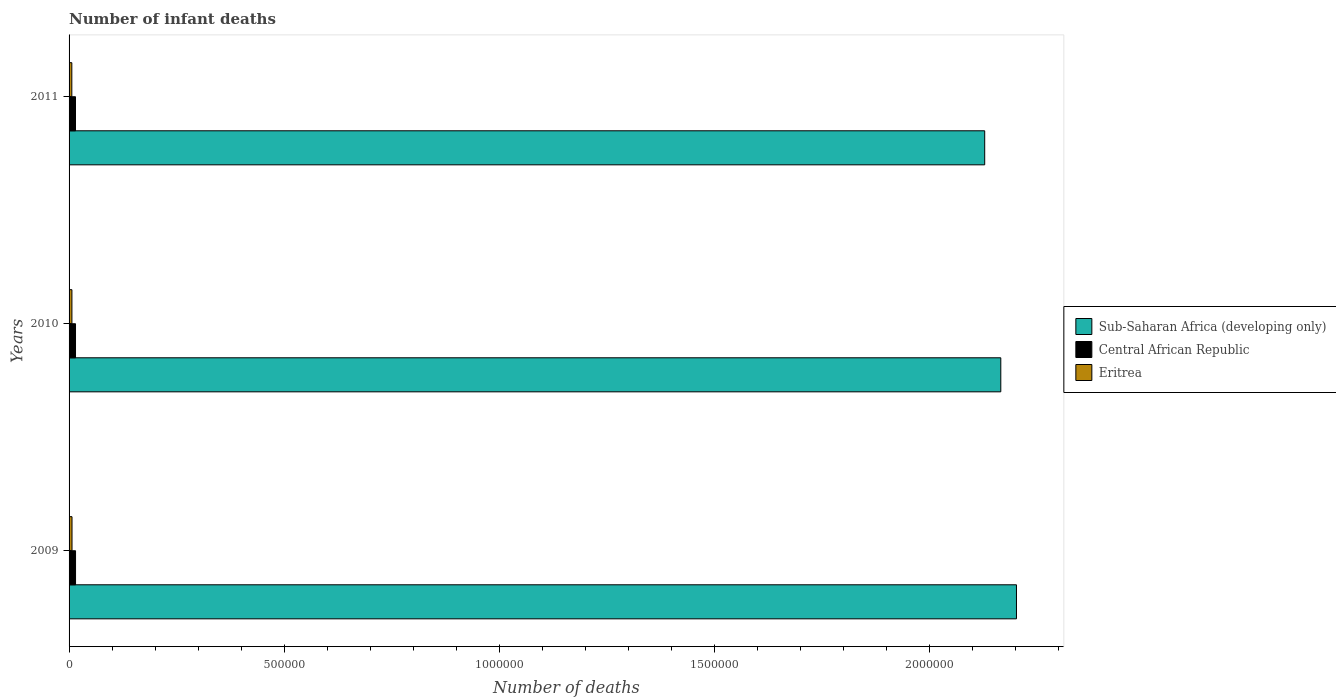How many groups of bars are there?
Provide a short and direct response. 3. Are the number of bars on each tick of the Y-axis equal?
Give a very brief answer. Yes. How many bars are there on the 1st tick from the bottom?
Your response must be concise. 3. What is the number of infant deaths in Sub-Saharan Africa (developing only) in 2009?
Provide a short and direct response. 2.20e+06. Across all years, what is the maximum number of infant deaths in Central African Republic?
Give a very brief answer. 1.51e+04. Across all years, what is the minimum number of infant deaths in Sub-Saharan Africa (developing only)?
Give a very brief answer. 2.13e+06. What is the total number of infant deaths in Eritrea in the graph?
Your answer should be very brief. 1.98e+04. What is the difference between the number of infant deaths in Eritrea in 2009 and that in 2011?
Ensure brevity in your answer.  431. What is the difference between the number of infant deaths in Eritrea in 2009 and the number of infant deaths in Sub-Saharan Africa (developing only) in 2011?
Give a very brief answer. -2.12e+06. What is the average number of infant deaths in Eritrea per year?
Ensure brevity in your answer.  6615.33. In the year 2010, what is the difference between the number of infant deaths in Sub-Saharan Africa (developing only) and number of infant deaths in Eritrea?
Provide a short and direct response. 2.16e+06. What is the ratio of the number of infant deaths in Eritrea in 2009 to that in 2011?
Your response must be concise. 1.07. Is the number of infant deaths in Central African Republic in 2009 less than that in 2011?
Offer a terse response. No. Is the difference between the number of infant deaths in Sub-Saharan Africa (developing only) in 2009 and 2011 greater than the difference between the number of infant deaths in Eritrea in 2009 and 2011?
Provide a succinct answer. Yes. What is the difference between the highest and the second highest number of infant deaths in Eritrea?
Provide a succinct answer. 210. What is the difference between the highest and the lowest number of infant deaths in Eritrea?
Offer a terse response. 431. Is the sum of the number of infant deaths in Central African Republic in 2009 and 2011 greater than the maximum number of infant deaths in Eritrea across all years?
Ensure brevity in your answer.  Yes. What does the 3rd bar from the top in 2010 represents?
Offer a terse response. Sub-Saharan Africa (developing only). What does the 1st bar from the bottom in 2009 represents?
Offer a terse response. Sub-Saharan Africa (developing only). Is it the case that in every year, the sum of the number of infant deaths in Eritrea and number of infant deaths in Central African Republic is greater than the number of infant deaths in Sub-Saharan Africa (developing only)?
Offer a terse response. No. Are all the bars in the graph horizontal?
Provide a succinct answer. Yes. What is the difference between two consecutive major ticks on the X-axis?
Your answer should be compact. 5.00e+05. Does the graph contain any zero values?
Make the answer very short. No. How many legend labels are there?
Your answer should be compact. 3. How are the legend labels stacked?
Provide a short and direct response. Vertical. What is the title of the graph?
Provide a succinct answer. Number of infant deaths. What is the label or title of the X-axis?
Provide a succinct answer. Number of deaths. What is the label or title of the Y-axis?
Make the answer very short. Years. What is the Number of deaths of Sub-Saharan Africa (developing only) in 2009?
Provide a short and direct response. 2.20e+06. What is the Number of deaths of Central African Republic in 2009?
Ensure brevity in your answer.  1.51e+04. What is the Number of deaths in Eritrea in 2009?
Your answer should be compact. 6829. What is the Number of deaths of Sub-Saharan Africa (developing only) in 2010?
Ensure brevity in your answer.  2.17e+06. What is the Number of deaths in Central African Republic in 2010?
Your answer should be very brief. 1.50e+04. What is the Number of deaths in Eritrea in 2010?
Your response must be concise. 6619. What is the Number of deaths of Sub-Saharan Africa (developing only) in 2011?
Your response must be concise. 2.13e+06. What is the Number of deaths of Central African Republic in 2011?
Offer a terse response. 1.49e+04. What is the Number of deaths of Eritrea in 2011?
Give a very brief answer. 6398. Across all years, what is the maximum Number of deaths of Sub-Saharan Africa (developing only)?
Offer a terse response. 2.20e+06. Across all years, what is the maximum Number of deaths of Central African Republic?
Your response must be concise. 1.51e+04. Across all years, what is the maximum Number of deaths of Eritrea?
Your answer should be very brief. 6829. Across all years, what is the minimum Number of deaths in Sub-Saharan Africa (developing only)?
Keep it short and to the point. 2.13e+06. Across all years, what is the minimum Number of deaths in Central African Republic?
Provide a short and direct response. 1.49e+04. Across all years, what is the minimum Number of deaths in Eritrea?
Give a very brief answer. 6398. What is the total Number of deaths of Sub-Saharan Africa (developing only) in the graph?
Provide a short and direct response. 6.50e+06. What is the total Number of deaths of Central African Republic in the graph?
Your response must be concise. 4.50e+04. What is the total Number of deaths of Eritrea in the graph?
Offer a terse response. 1.98e+04. What is the difference between the Number of deaths in Sub-Saharan Africa (developing only) in 2009 and that in 2010?
Ensure brevity in your answer.  3.64e+04. What is the difference between the Number of deaths in Central African Republic in 2009 and that in 2010?
Offer a very short reply. 89. What is the difference between the Number of deaths in Eritrea in 2009 and that in 2010?
Give a very brief answer. 210. What is the difference between the Number of deaths in Sub-Saharan Africa (developing only) in 2009 and that in 2011?
Your answer should be very brief. 7.38e+04. What is the difference between the Number of deaths in Central African Republic in 2009 and that in 2011?
Provide a succinct answer. 122. What is the difference between the Number of deaths of Eritrea in 2009 and that in 2011?
Your answer should be compact. 431. What is the difference between the Number of deaths in Sub-Saharan Africa (developing only) in 2010 and that in 2011?
Provide a succinct answer. 3.74e+04. What is the difference between the Number of deaths of Central African Republic in 2010 and that in 2011?
Provide a succinct answer. 33. What is the difference between the Number of deaths in Eritrea in 2010 and that in 2011?
Provide a short and direct response. 221. What is the difference between the Number of deaths of Sub-Saharan Africa (developing only) in 2009 and the Number of deaths of Central African Republic in 2010?
Your answer should be very brief. 2.19e+06. What is the difference between the Number of deaths in Sub-Saharan Africa (developing only) in 2009 and the Number of deaths in Eritrea in 2010?
Offer a very short reply. 2.20e+06. What is the difference between the Number of deaths in Central African Republic in 2009 and the Number of deaths in Eritrea in 2010?
Offer a terse response. 8439. What is the difference between the Number of deaths of Sub-Saharan Africa (developing only) in 2009 and the Number of deaths of Central African Republic in 2011?
Your response must be concise. 2.19e+06. What is the difference between the Number of deaths of Sub-Saharan Africa (developing only) in 2009 and the Number of deaths of Eritrea in 2011?
Keep it short and to the point. 2.20e+06. What is the difference between the Number of deaths in Central African Republic in 2009 and the Number of deaths in Eritrea in 2011?
Offer a terse response. 8660. What is the difference between the Number of deaths in Sub-Saharan Africa (developing only) in 2010 and the Number of deaths in Central African Republic in 2011?
Make the answer very short. 2.15e+06. What is the difference between the Number of deaths in Sub-Saharan Africa (developing only) in 2010 and the Number of deaths in Eritrea in 2011?
Give a very brief answer. 2.16e+06. What is the difference between the Number of deaths of Central African Republic in 2010 and the Number of deaths of Eritrea in 2011?
Give a very brief answer. 8571. What is the average Number of deaths of Sub-Saharan Africa (developing only) per year?
Provide a short and direct response. 2.17e+06. What is the average Number of deaths in Central African Republic per year?
Give a very brief answer. 1.50e+04. What is the average Number of deaths of Eritrea per year?
Offer a terse response. 6615.33. In the year 2009, what is the difference between the Number of deaths in Sub-Saharan Africa (developing only) and Number of deaths in Central African Republic?
Make the answer very short. 2.19e+06. In the year 2009, what is the difference between the Number of deaths in Sub-Saharan Africa (developing only) and Number of deaths in Eritrea?
Make the answer very short. 2.20e+06. In the year 2009, what is the difference between the Number of deaths in Central African Republic and Number of deaths in Eritrea?
Offer a terse response. 8229. In the year 2010, what is the difference between the Number of deaths in Sub-Saharan Africa (developing only) and Number of deaths in Central African Republic?
Keep it short and to the point. 2.15e+06. In the year 2010, what is the difference between the Number of deaths in Sub-Saharan Africa (developing only) and Number of deaths in Eritrea?
Your answer should be compact. 2.16e+06. In the year 2010, what is the difference between the Number of deaths in Central African Republic and Number of deaths in Eritrea?
Ensure brevity in your answer.  8350. In the year 2011, what is the difference between the Number of deaths in Sub-Saharan Africa (developing only) and Number of deaths in Central African Republic?
Offer a very short reply. 2.11e+06. In the year 2011, what is the difference between the Number of deaths in Sub-Saharan Africa (developing only) and Number of deaths in Eritrea?
Offer a terse response. 2.12e+06. In the year 2011, what is the difference between the Number of deaths of Central African Republic and Number of deaths of Eritrea?
Your answer should be compact. 8538. What is the ratio of the Number of deaths in Sub-Saharan Africa (developing only) in 2009 to that in 2010?
Provide a short and direct response. 1.02. What is the ratio of the Number of deaths in Central African Republic in 2009 to that in 2010?
Keep it short and to the point. 1.01. What is the ratio of the Number of deaths in Eritrea in 2009 to that in 2010?
Your answer should be compact. 1.03. What is the ratio of the Number of deaths of Sub-Saharan Africa (developing only) in 2009 to that in 2011?
Offer a terse response. 1.03. What is the ratio of the Number of deaths of Central African Republic in 2009 to that in 2011?
Offer a terse response. 1.01. What is the ratio of the Number of deaths in Eritrea in 2009 to that in 2011?
Your answer should be compact. 1.07. What is the ratio of the Number of deaths of Sub-Saharan Africa (developing only) in 2010 to that in 2011?
Your answer should be very brief. 1.02. What is the ratio of the Number of deaths in Eritrea in 2010 to that in 2011?
Give a very brief answer. 1.03. What is the difference between the highest and the second highest Number of deaths in Sub-Saharan Africa (developing only)?
Provide a short and direct response. 3.64e+04. What is the difference between the highest and the second highest Number of deaths in Central African Republic?
Keep it short and to the point. 89. What is the difference between the highest and the second highest Number of deaths in Eritrea?
Give a very brief answer. 210. What is the difference between the highest and the lowest Number of deaths in Sub-Saharan Africa (developing only)?
Keep it short and to the point. 7.38e+04. What is the difference between the highest and the lowest Number of deaths of Central African Republic?
Provide a short and direct response. 122. What is the difference between the highest and the lowest Number of deaths of Eritrea?
Your response must be concise. 431. 